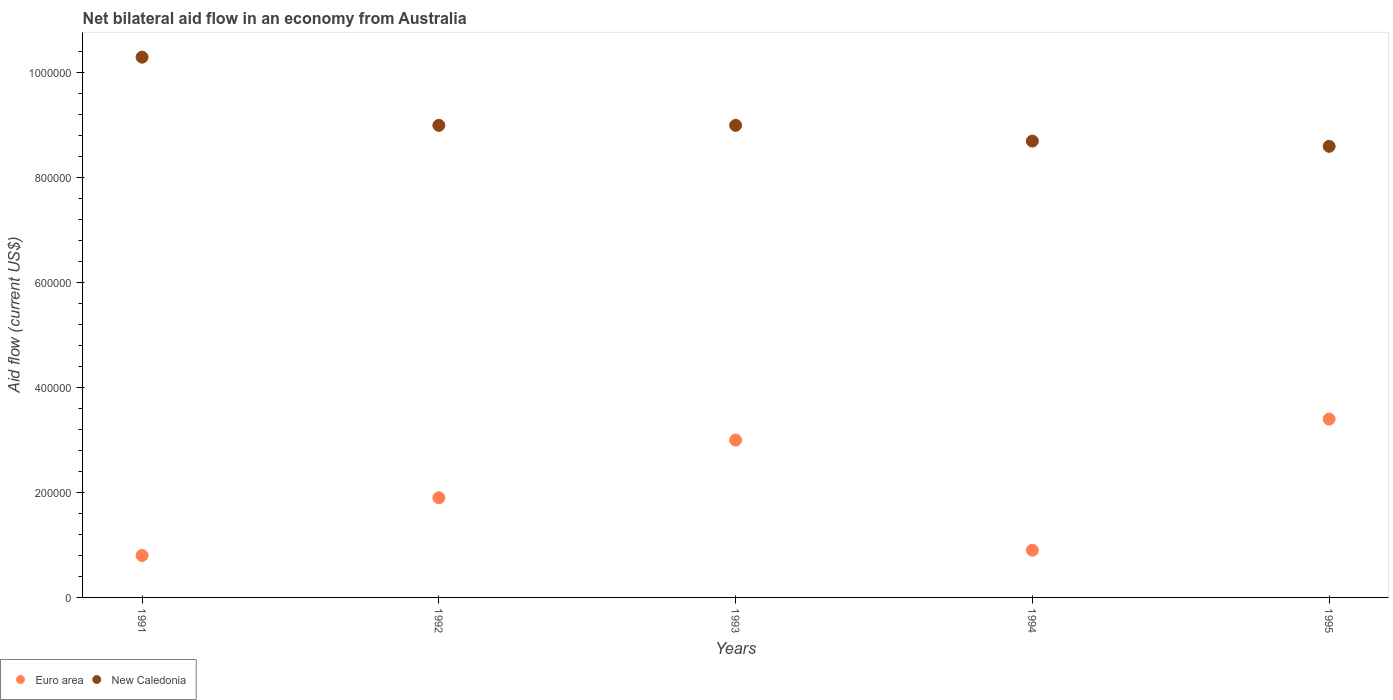How many different coloured dotlines are there?
Ensure brevity in your answer.  2. What is the net bilateral aid flow in New Caledonia in 1991?
Your response must be concise. 1.03e+06. Across all years, what is the maximum net bilateral aid flow in New Caledonia?
Provide a short and direct response. 1.03e+06. Across all years, what is the minimum net bilateral aid flow in Euro area?
Give a very brief answer. 8.00e+04. In which year was the net bilateral aid flow in New Caledonia maximum?
Give a very brief answer. 1991. In which year was the net bilateral aid flow in New Caledonia minimum?
Your answer should be very brief. 1995. What is the total net bilateral aid flow in Euro area in the graph?
Offer a terse response. 1.00e+06. What is the difference between the net bilateral aid flow in New Caledonia in 1991 and the net bilateral aid flow in Euro area in 1995?
Your answer should be very brief. 6.90e+05. In the year 1993, what is the difference between the net bilateral aid flow in Euro area and net bilateral aid flow in New Caledonia?
Make the answer very short. -6.00e+05. In how many years, is the net bilateral aid flow in Euro area greater than 280000 US$?
Your response must be concise. 2. What is the ratio of the net bilateral aid flow in New Caledonia in 1994 to that in 1995?
Your answer should be very brief. 1.01. What is the difference between the highest and the second highest net bilateral aid flow in Euro area?
Offer a terse response. 4.00e+04. In how many years, is the net bilateral aid flow in New Caledonia greater than the average net bilateral aid flow in New Caledonia taken over all years?
Your answer should be compact. 1. Is the sum of the net bilateral aid flow in Euro area in 1991 and 1994 greater than the maximum net bilateral aid flow in New Caledonia across all years?
Give a very brief answer. No. Does the net bilateral aid flow in New Caledonia monotonically increase over the years?
Your answer should be compact. No. Is the net bilateral aid flow in Euro area strictly greater than the net bilateral aid flow in New Caledonia over the years?
Your answer should be very brief. No. What is the difference between two consecutive major ticks on the Y-axis?
Make the answer very short. 2.00e+05. Does the graph contain any zero values?
Keep it short and to the point. No. Does the graph contain grids?
Offer a terse response. No. Where does the legend appear in the graph?
Give a very brief answer. Bottom left. How many legend labels are there?
Your answer should be compact. 2. How are the legend labels stacked?
Ensure brevity in your answer.  Horizontal. What is the title of the graph?
Your response must be concise. Net bilateral aid flow in an economy from Australia. What is the label or title of the X-axis?
Provide a short and direct response. Years. What is the Aid flow (current US$) of New Caledonia in 1991?
Provide a short and direct response. 1.03e+06. What is the Aid flow (current US$) in New Caledonia in 1992?
Your answer should be compact. 9.00e+05. What is the Aid flow (current US$) of Euro area in 1993?
Your response must be concise. 3.00e+05. What is the Aid flow (current US$) of New Caledonia in 1993?
Make the answer very short. 9.00e+05. What is the Aid flow (current US$) in New Caledonia in 1994?
Provide a short and direct response. 8.70e+05. What is the Aid flow (current US$) of New Caledonia in 1995?
Offer a terse response. 8.60e+05. Across all years, what is the maximum Aid flow (current US$) in Euro area?
Your answer should be compact. 3.40e+05. Across all years, what is the maximum Aid flow (current US$) in New Caledonia?
Your response must be concise. 1.03e+06. Across all years, what is the minimum Aid flow (current US$) in Euro area?
Your answer should be compact. 8.00e+04. Across all years, what is the minimum Aid flow (current US$) of New Caledonia?
Make the answer very short. 8.60e+05. What is the total Aid flow (current US$) of Euro area in the graph?
Offer a very short reply. 1.00e+06. What is the total Aid flow (current US$) in New Caledonia in the graph?
Provide a succinct answer. 4.56e+06. What is the difference between the Aid flow (current US$) of Euro area in 1991 and that in 1992?
Keep it short and to the point. -1.10e+05. What is the difference between the Aid flow (current US$) in New Caledonia in 1991 and that in 1992?
Offer a very short reply. 1.30e+05. What is the difference between the Aid flow (current US$) of Euro area in 1991 and that in 1993?
Ensure brevity in your answer.  -2.20e+05. What is the difference between the Aid flow (current US$) of Euro area in 1991 and that in 1994?
Your response must be concise. -10000. What is the difference between the Aid flow (current US$) in New Caledonia in 1991 and that in 1994?
Keep it short and to the point. 1.60e+05. What is the difference between the Aid flow (current US$) in Euro area in 1992 and that in 1993?
Offer a very short reply. -1.10e+05. What is the difference between the Aid flow (current US$) in Euro area in 1992 and that in 1994?
Make the answer very short. 1.00e+05. What is the difference between the Aid flow (current US$) of Euro area in 1992 and that in 1995?
Keep it short and to the point. -1.50e+05. What is the difference between the Aid flow (current US$) in New Caledonia in 1993 and that in 1994?
Your answer should be compact. 3.00e+04. What is the difference between the Aid flow (current US$) in Euro area in 1991 and the Aid flow (current US$) in New Caledonia in 1992?
Your response must be concise. -8.20e+05. What is the difference between the Aid flow (current US$) of Euro area in 1991 and the Aid flow (current US$) of New Caledonia in 1993?
Offer a very short reply. -8.20e+05. What is the difference between the Aid flow (current US$) of Euro area in 1991 and the Aid flow (current US$) of New Caledonia in 1994?
Your response must be concise. -7.90e+05. What is the difference between the Aid flow (current US$) of Euro area in 1991 and the Aid flow (current US$) of New Caledonia in 1995?
Your answer should be compact. -7.80e+05. What is the difference between the Aid flow (current US$) of Euro area in 1992 and the Aid flow (current US$) of New Caledonia in 1993?
Your answer should be very brief. -7.10e+05. What is the difference between the Aid flow (current US$) in Euro area in 1992 and the Aid flow (current US$) in New Caledonia in 1994?
Your response must be concise. -6.80e+05. What is the difference between the Aid flow (current US$) in Euro area in 1992 and the Aid flow (current US$) in New Caledonia in 1995?
Keep it short and to the point. -6.70e+05. What is the difference between the Aid flow (current US$) of Euro area in 1993 and the Aid flow (current US$) of New Caledonia in 1994?
Offer a very short reply. -5.70e+05. What is the difference between the Aid flow (current US$) of Euro area in 1993 and the Aid flow (current US$) of New Caledonia in 1995?
Provide a short and direct response. -5.60e+05. What is the difference between the Aid flow (current US$) of Euro area in 1994 and the Aid flow (current US$) of New Caledonia in 1995?
Your response must be concise. -7.70e+05. What is the average Aid flow (current US$) of Euro area per year?
Make the answer very short. 2.00e+05. What is the average Aid flow (current US$) in New Caledonia per year?
Your answer should be very brief. 9.12e+05. In the year 1991, what is the difference between the Aid flow (current US$) of Euro area and Aid flow (current US$) of New Caledonia?
Offer a terse response. -9.50e+05. In the year 1992, what is the difference between the Aid flow (current US$) in Euro area and Aid flow (current US$) in New Caledonia?
Make the answer very short. -7.10e+05. In the year 1993, what is the difference between the Aid flow (current US$) in Euro area and Aid flow (current US$) in New Caledonia?
Ensure brevity in your answer.  -6.00e+05. In the year 1994, what is the difference between the Aid flow (current US$) of Euro area and Aid flow (current US$) of New Caledonia?
Make the answer very short. -7.80e+05. In the year 1995, what is the difference between the Aid flow (current US$) of Euro area and Aid flow (current US$) of New Caledonia?
Your answer should be very brief. -5.20e+05. What is the ratio of the Aid flow (current US$) in Euro area in 1991 to that in 1992?
Ensure brevity in your answer.  0.42. What is the ratio of the Aid flow (current US$) in New Caledonia in 1991 to that in 1992?
Keep it short and to the point. 1.14. What is the ratio of the Aid flow (current US$) of Euro area in 1991 to that in 1993?
Offer a very short reply. 0.27. What is the ratio of the Aid flow (current US$) of New Caledonia in 1991 to that in 1993?
Your answer should be compact. 1.14. What is the ratio of the Aid flow (current US$) in New Caledonia in 1991 to that in 1994?
Your answer should be very brief. 1.18. What is the ratio of the Aid flow (current US$) in Euro area in 1991 to that in 1995?
Provide a short and direct response. 0.24. What is the ratio of the Aid flow (current US$) of New Caledonia in 1991 to that in 1995?
Provide a succinct answer. 1.2. What is the ratio of the Aid flow (current US$) in Euro area in 1992 to that in 1993?
Provide a short and direct response. 0.63. What is the ratio of the Aid flow (current US$) of Euro area in 1992 to that in 1994?
Keep it short and to the point. 2.11. What is the ratio of the Aid flow (current US$) in New Caledonia in 1992 to that in 1994?
Provide a short and direct response. 1.03. What is the ratio of the Aid flow (current US$) of Euro area in 1992 to that in 1995?
Make the answer very short. 0.56. What is the ratio of the Aid flow (current US$) in New Caledonia in 1992 to that in 1995?
Your answer should be compact. 1.05. What is the ratio of the Aid flow (current US$) in Euro area in 1993 to that in 1994?
Your answer should be compact. 3.33. What is the ratio of the Aid flow (current US$) in New Caledonia in 1993 to that in 1994?
Your response must be concise. 1.03. What is the ratio of the Aid flow (current US$) of Euro area in 1993 to that in 1995?
Your answer should be compact. 0.88. What is the ratio of the Aid flow (current US$) in New Caledonia in 1993 to that in 1995?
Offer a very short reply. 1.05. What is the ratio of the Aid flow (current US$) of Euro area in 1994 to that in 1995?
Keep it short and to the point. 0.26. What is the ratio of the Aid flow (current US$) in New Caledonia in 1994 to that in 1995?
Provide a short and direct response. 1.01. What is the difference between the highest and the lowest Aid flow (current US$) in Euro area?
Your answer should be very brief. 2.60e+05. 